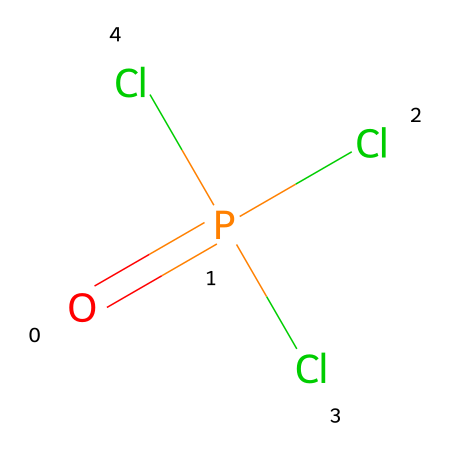What is the total number of chlorine atoms in this chemical? The SMILES representation shows three chlorine (Cl) atoms attached to the phosphorus (P) atom. Counting them directly from the structure indicates there are three chlorine atoms.
Answer: three What is the oxidation state of phosphorus in this compound? The oxidation state can be determined by considering the bonding: phosphorus typically has an oxidation state of +5 when bonded with three chlorine atoms and one oxygen atom, as is the case here.
Answer: +5 How many total atoms are present in this compound? In the given structure, there are one phosphorus atom, one oxygen atom, and three chlorine atoms. Adding these together gives a total of five atoms.
Answer: five What chemical category does phosphorus oxychloride belong to? This compound is categorized as a phosphorus oxichloride, specifically due to the presence of both oxygen and chlorine atoms bonded to phosphorus.
Answer: phosphorus oxichloride Which atom serves as the central atom in this molecule? In the given structure, phosphorus (P) is the central atom, with chlorine and oxygen atoms surrounding it, indicating its role as the core element in the molecular framework.
Answer: phosphorus What kind of bonds are present between phosphorus and chlorine in this molecule? The phosphorus atom forms covalent bonds with the chlorine atoms. This can be deduced from the absence of ionic charges and the sharing of electrons typical of covalent interactions.
Answer: covalent bonds What effect does the presence of chlorine have on the properties of this compound? Chlorine's influence introduces reactivity and potent electrophilic properties to the phosphorus oxychloride, impacting its behavior in chemical reactions, particularly in solar cell manufacturing.
Answer: reactivity 